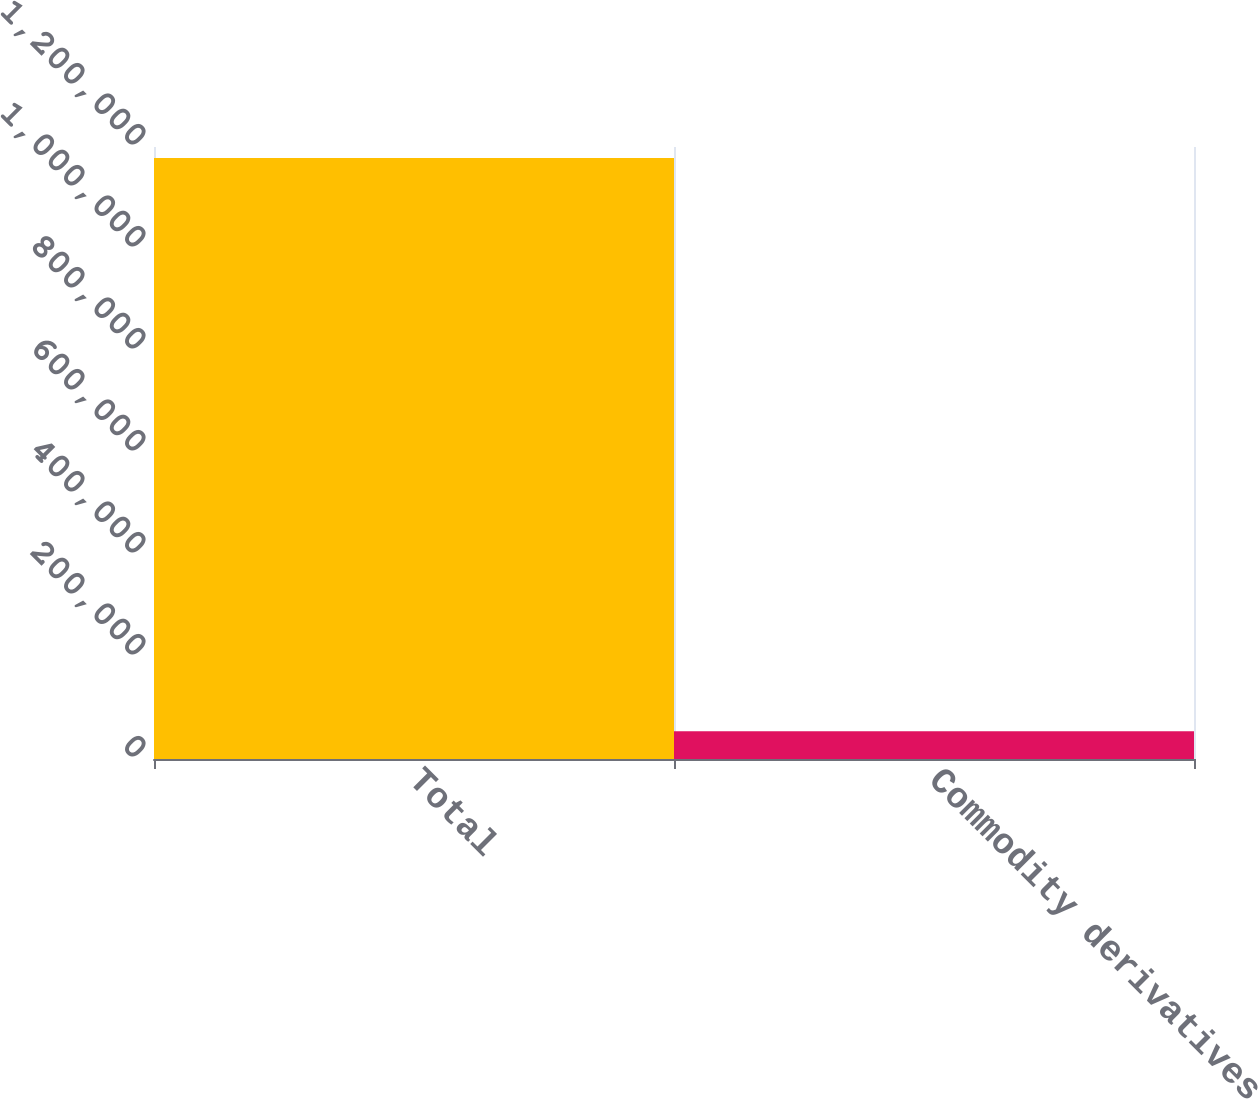Convert chart to OTSL. <chart><loc_0><loc_0><loc_500><loc_500><bar_chart><fcel>Total<fcel>Commodity derivatives<nl><fcel>1.17826e+06<fcel>54307<nl></chart> 